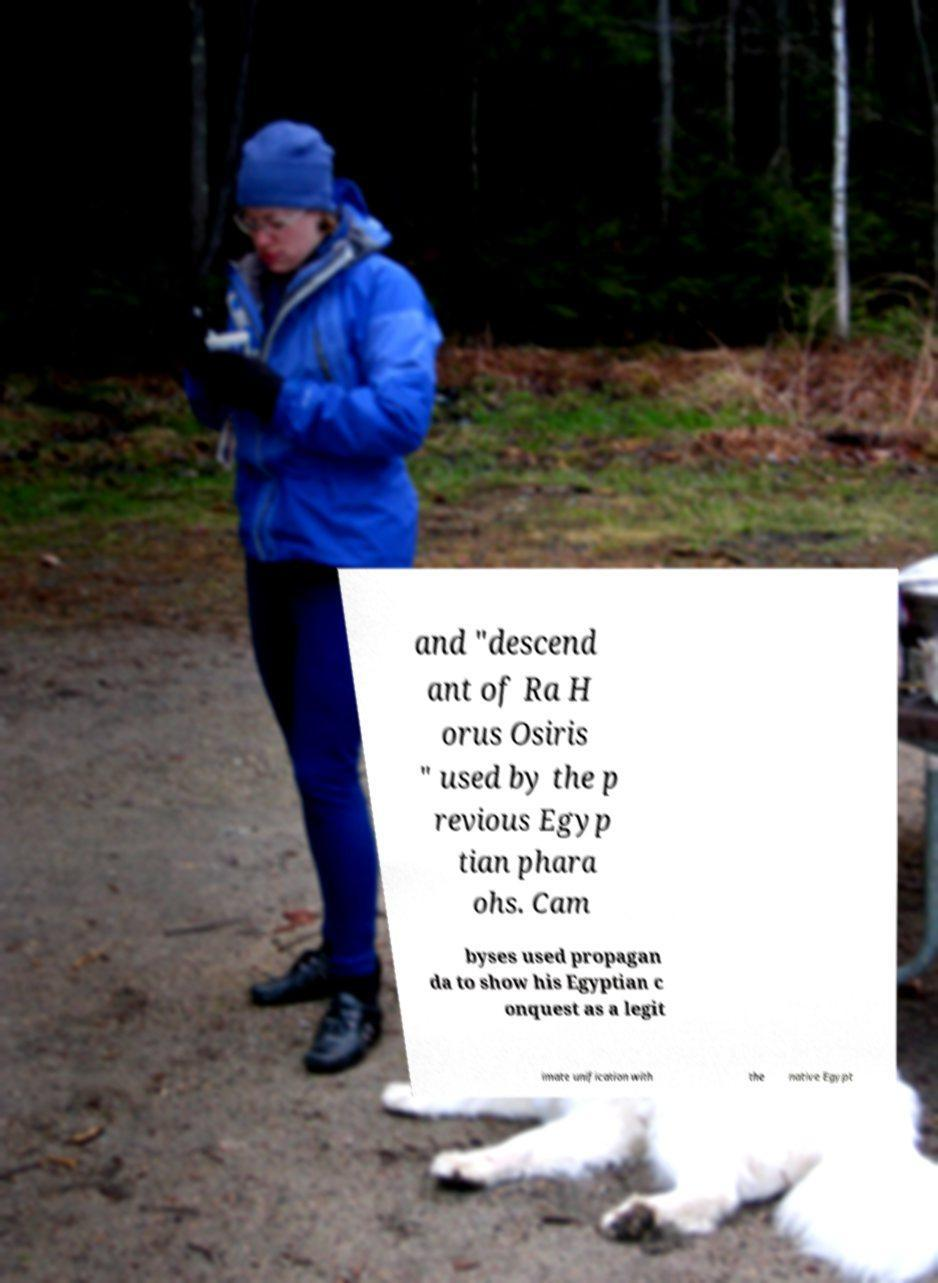I need the written content from this picture converted into text. Can you do that? and "descend ant of Ra H orus Osiris " used by the p revious Egyp tian phara ohs. Cam byses used propagan da to show his Egyptian c onquest as a legit imate unification with the native Egypt 